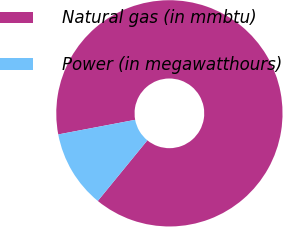Convert chart to OTSL. <chart><loc_0><loc_0><loc_500><loc_500><pie_chart><fcel>Natural gas (in mmbtu)<fcel>Power (in megawatthours)<nl><fcel>88.89%<fcel>11.11%<nl></chart> 